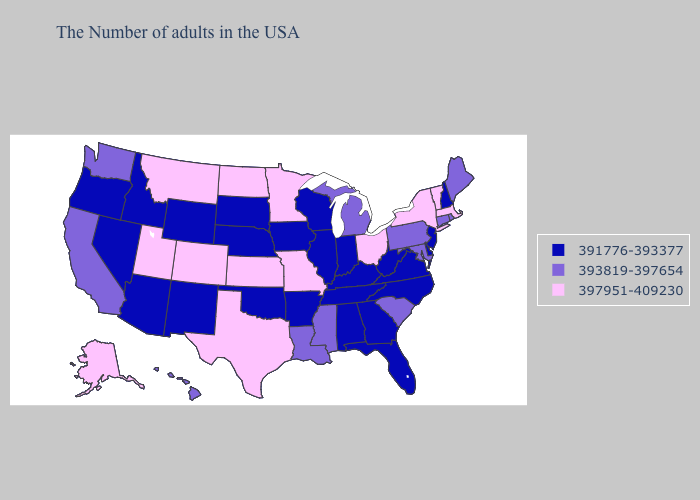What is the value of Arizona?
Write a very short answer. 391776-393377. Does Massachusetts have the highest value in the USA?
Short answer required. Yes. What is the highest value in states that border Mississippi?
Keep it brief. 393819-397654. Does the first symbol in the legend represent the smallest category?
Be succinct. Yes. What is the lowest value in the Northeast?
Give a very brief answer. 391776-393377. What is the value of Georgia?
Keep it brief. 391776-393377. What is the value of Washington?
Short answer required. 393819-397654. What is the value of Louisiana?
Quick response, please. 393819-397654. What is the value of Pennsylvania?
Concise answer only. 393819-397654. What is the value of Nevada?
Answer briefly. 391776-393377. What is the lowest value in the USA?
Quick response, please. 391776-393377. Among the states that border Alabama , which have the highest value?
Give a very brief answer. Mississippi. Does Florida have a lower value than Alabama?
Write a very short answer. No. How many symbols are there in the legend?
Quick response, please. 3. Among the states that border Arizona , which have the highest value?
Answer briefly. Colorado, Utah. 